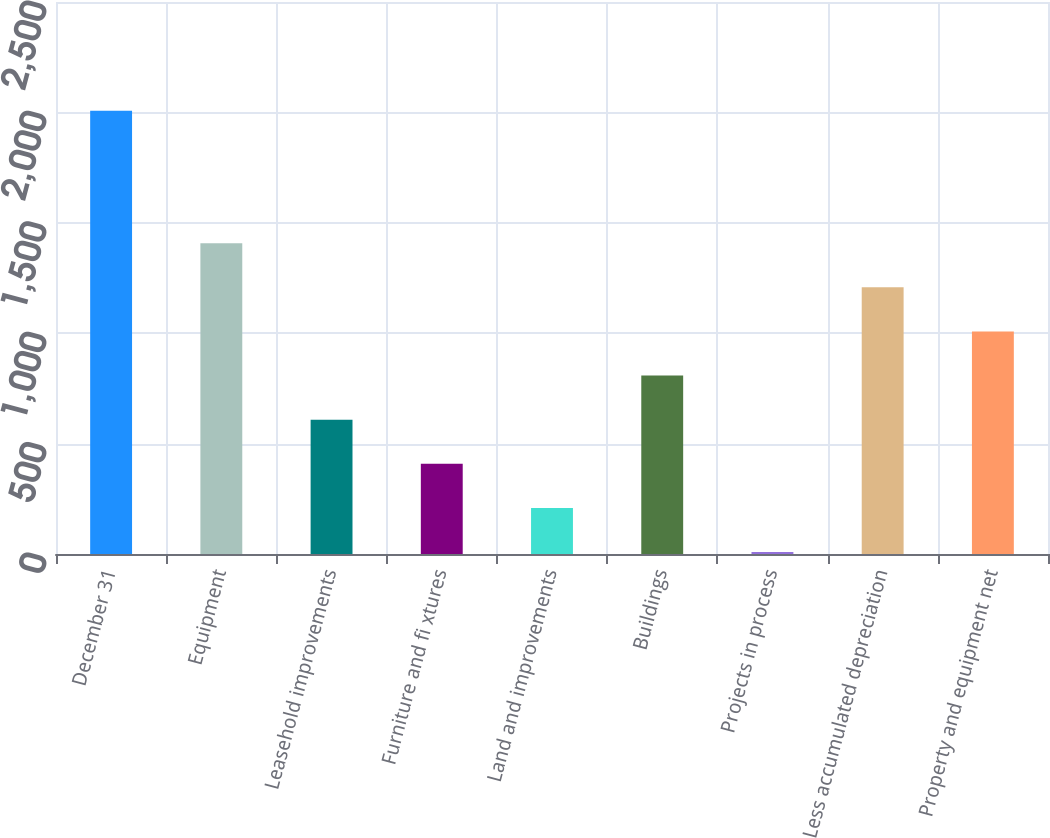Convert chart. <chart><loc_0><loc_0><loc_500><loc_500><bar_chart><fcel>December 31<fcel>Equipment<fcel>Leasehold improvements<fcel>Furniture and fi xtures<fcel>Land and improvements<fcel>Buildings<fcel>Projects in process<fcel>Less accumulated depreciation<fcel>Property and equipment net<nl><fcel>2007<fcel>1407.54<fcel>608.26<fcel>408.44<fcel>208.62<fcel>808.08<fcel>8.8<fcel>1207.72<fcel>1007.9<nl></chart> 